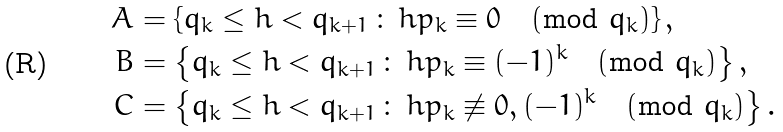<formula> <loc_0><loc_0><loc_500><loc_500>A & = \left \{ q _ { k } \leq h < q _ { k + 1 } \, \colon \, h p _ { k } \equiv 0 \pmod { q _ { k } } \right \} , \\ B & = \left \{ q _ { k } \leq h < q _ { k + 1 } \, \colon \, h p _ { k } \equiv ( - 1 ) ^ { k } \pmod { q _ { k } } \right \} , \\ C & = \left \{ q _ { k } \leq h < q _ { k + 1 } \, \colon \, h p _ { k } \not \equiv 0 , ( - 1 ) ^ { k } \pmod { q _ { k } } \right \} .</formula> 